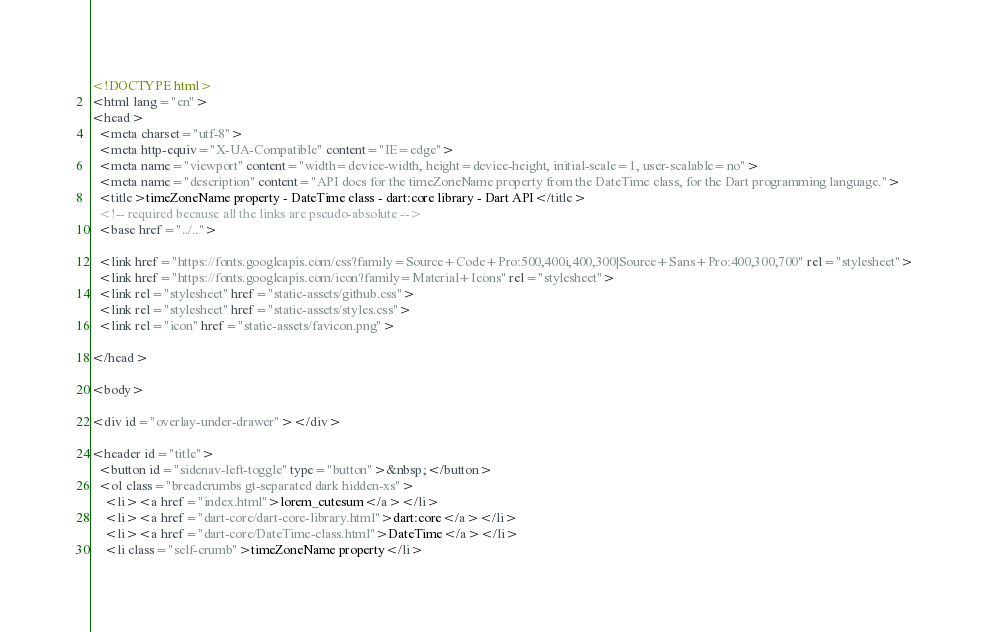<code> <loc_0><loc_0><loc_500><loc_500><_HTML_><!DOCTYPE html>
<html lang="en">
<head>
  <meta charset="utf-8">
  <meta http-equiv="X-UA-Compatible" content="IE=edge">
  <meta name="viewport" content="width=device-width, height=device-height, initial-scale=1, user-scalable=no">
  <meta name="description" content="API docs for the timeZoneName property from the DateTime class, for the Dart programming language.">
  <title>timeZoneName property - DateTime class - dart:core library - Dart API</title>
  <!-- required because all the links are pseudo-absolute -->
  <base href="../..">

  <link href="https://fonts.googleapis.com/css?family=Source+Code+Pro:500,400i,400,300|Source+Sans+Pro:400,300,700" rel="stylesheet">
  <link href="https://fonts.googleapis.com/icon?family=Material+Icons" rel="stylesheet">
  <link rel="stylesheet" href="static-assets/github.css">
  <link rel="stylesheet" href="static-assets/styles.css">
  <link rel="icon" href="static-assets/favicon.png">
  
</head>

<body>

<div id="overlay-under-drawer"></div>

<header id="title">
  <button id="sidenav-left-toggle" type="button">&nbsp;</button>
  <ol class="breadcrumbs gt-separated dark hidden-xs">
    <li><a href="index.html">lorem_cutesum</a></li>
    <li><a href="dart-core/dart-core-library.html">dart:core</a></li>
    <li><a href="dart-core/DateTime-class.html">DateTime</a></li>
    <li class="self-crumb">timeZoneName property</li></code> 